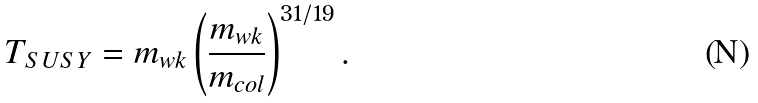<formula> <loc_0><loc_0><loc_500><loc_500>T _ { S U S Y } = m _ { w k } \left ( \frac { m _ { w k } } { m _ { c o l } } \right ) ^ { 3 1 / 1 9 } .</formula> 